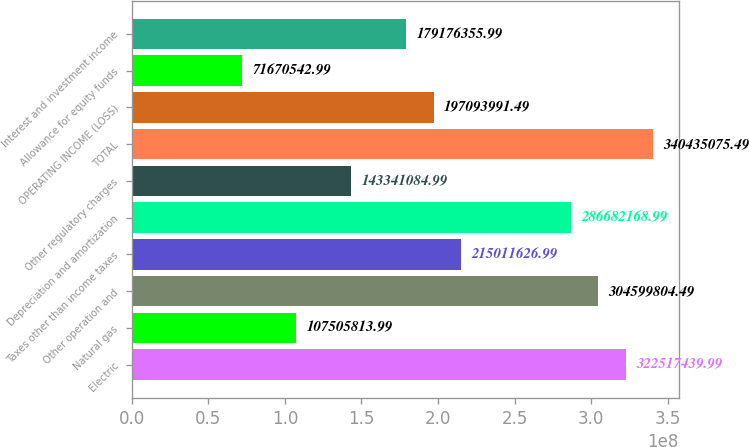<chart> <loc_0><loc_0><loc_500><loc_500><bar_chart><fcel>Electric<fcel>Natural gas<fcel>Other operation and<fcel>Taxes other than income taxes<fcel>Depreciation and amortization<fcel>Other regulatory charges<fcel>TOTAL<fcel>OPERATING INCOME (LOSS)<fcel>Allowance for equity funds<fcel>Interest and investment income<nl><fcel>3.22517e+08<fcel>1.07506e+08<fcel>3.046e+08<fcel>2.15012e+08<fcel>2.86682e+08<fcel>1.43341e+08<fcel>3.40435e+08<fcel>1.97094e+08<fcel>7.16705e+07<fcel>1.79176e+08<nl></chart> 